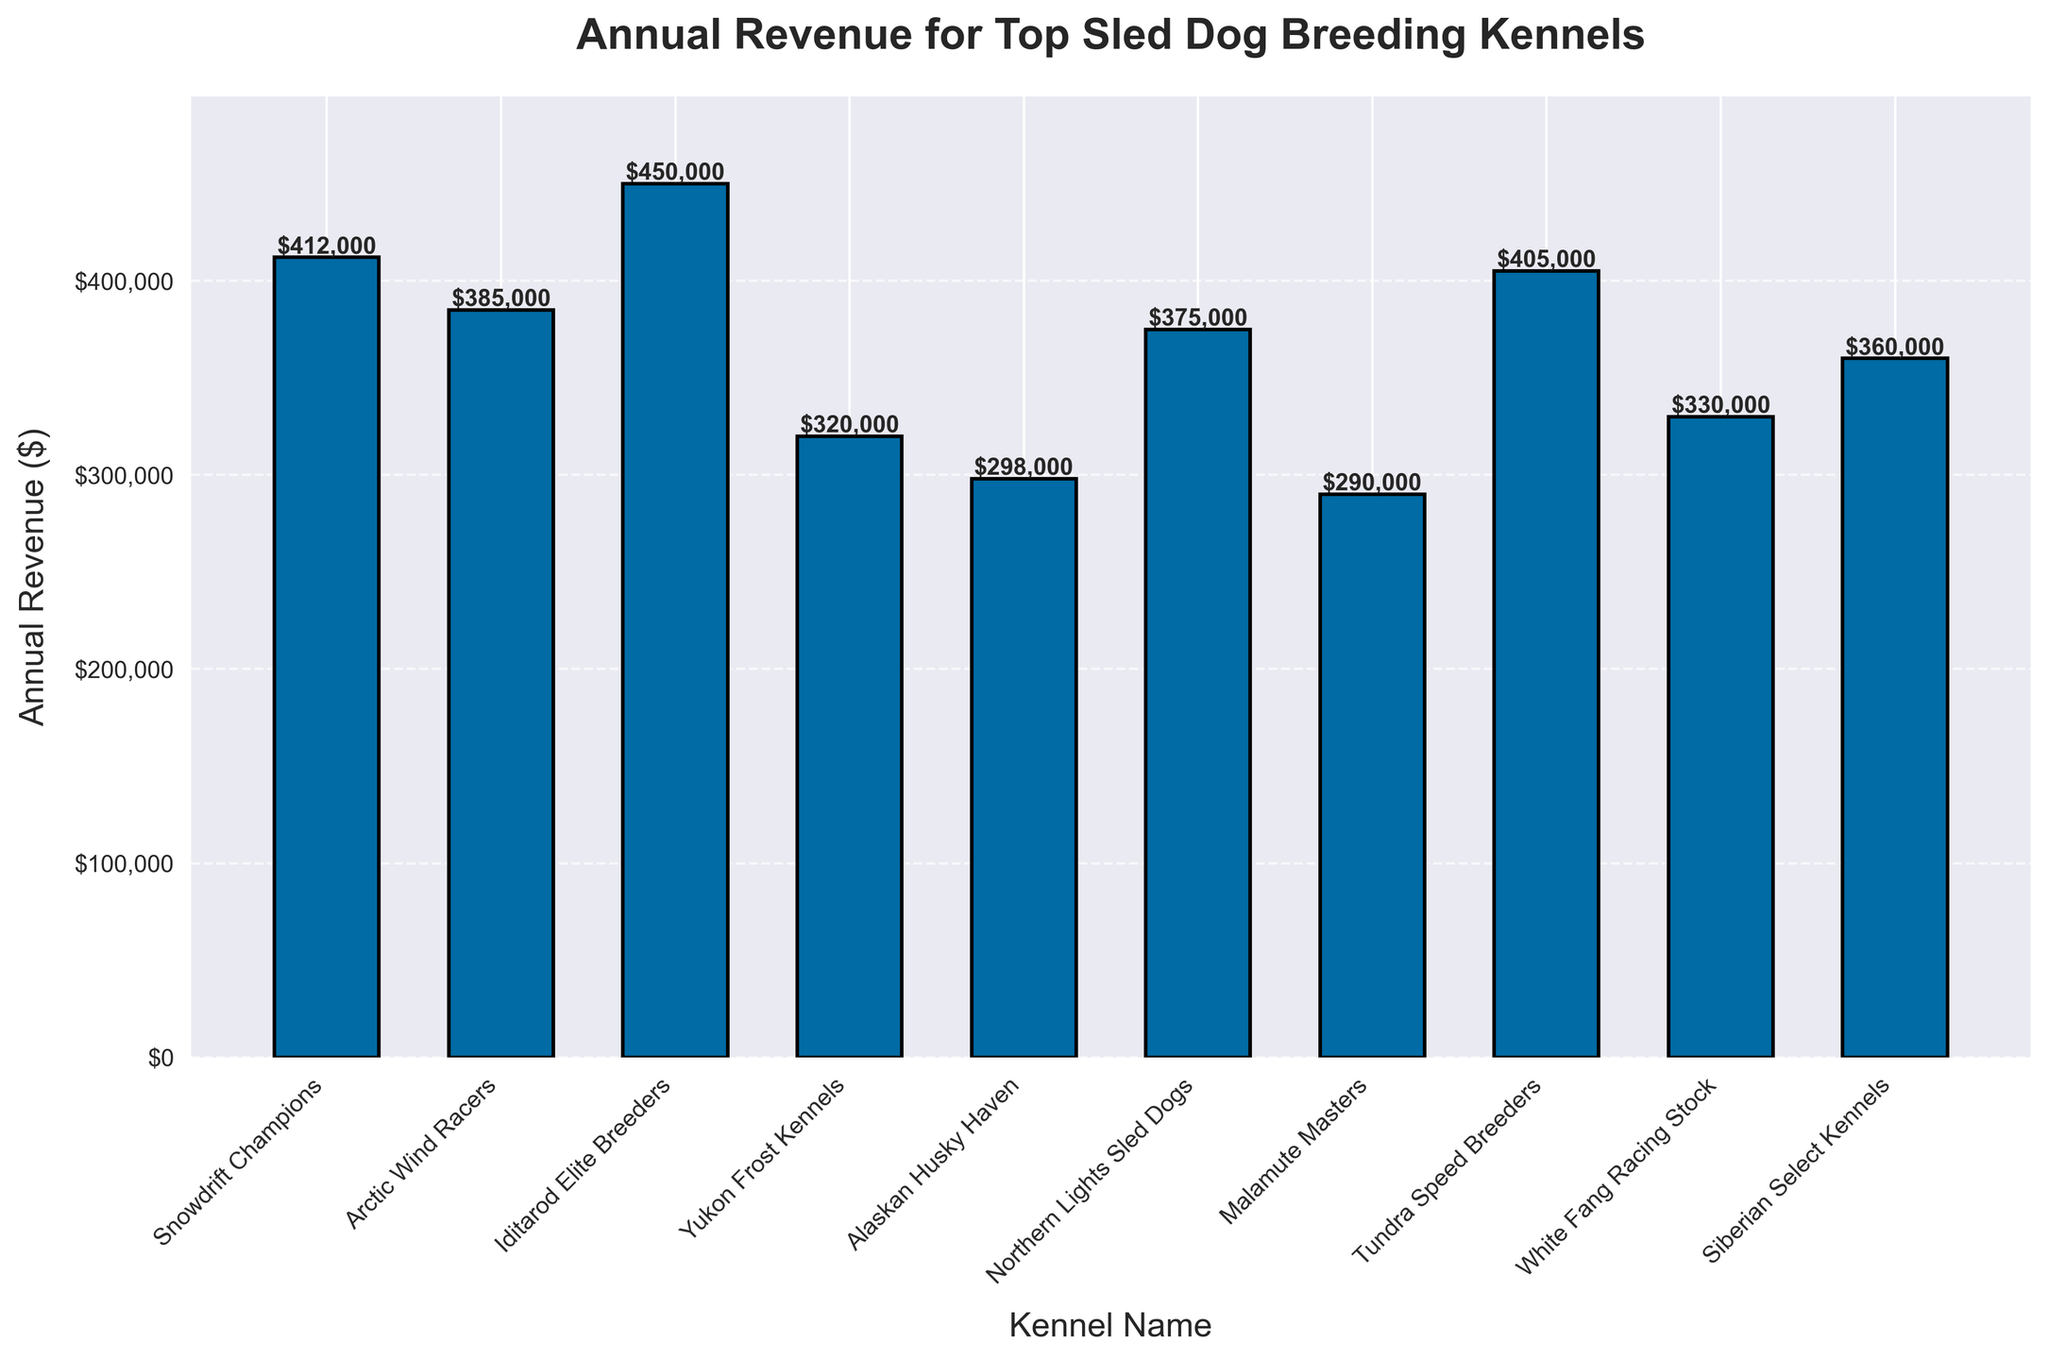Which kennel has the highest annual revenue? By examining the heights of the bars, the kennel with the highest bar represents the highest annual revenue. "Iditarod Elite Breeders" has the highest bar.
Answer: Iditarod Elite Breeders What is the total annual revenue of Artic Wind Racers and Tundra Speed Breeders? Add the annual revenue values of "Arctic Wind Racers" ($385,000) and "Tundra Speed Breeders" ($405,000). The total is $385,000 + $405,000.
Answer: $790,000 Which kennel shows the lowest annual revenue? By focusing on the shortest bar in the chart, "Alaskan Husky Haven" has the shortest bar indicating the lowest annual revenue.
Answer: Alaskan Husky Haven What is the difference in annual revenue between Northern Lights Sled Dogs and White Fang Racing Stock? Subtract the annual revenue of White Fang Racing Stock ($330,000) from Northern Lights Sled Dogs ($375,000). $375,000 - $330,000.
Answer: $45,000 How much more revenue does Snowdrift Champions generate compared to Malamute Masters? Subtract the revenue of Malamute Masters ($290,000) from Snowdrift Champions ($412,000). $412,000 - $290,000.
Answer: $122,000 What is the average annual revenue of all listed kennels? Sum all the annual revenues and divide by the number of kennels. (412,000 + 385,000 + 450,000 + 320,000 + 298,000 + 375,000 + 290,000 + 405,000 + 330,000 + 360,000) / 10.
Answer: $362,500 Which kennels have an annual revenue greater than $400,000? Identify the kennels with bars higher than the $400,000 mark: "Snowdrift Champions," "Iditarod Elite Breeders," and "Tundra Speed Breeders."
Answer: Snowdrift Champions, Iditarod Elite Breeders, Tundra Speed Breeders What is the median annual revenue of the kennels? Order the kennels' revenues and find the middle value. Ordered: 290,000, 298,000, 320,000, 330,000, 360,000, 375,000, 385,000, 405,000, 412,000, 450,000. Middle value is (360,000 + 375,000) / 2.
Answer: $367,500 Which kennel had a larger annual revenue, Siberian Select Kennels or Yukon Frost Kennels, and by how much? Subtract the lower annual revenue from the higher one. Siberian Select Kennels ($360,000) - Yukon Frost Kennels ($320,000).
Answer: $40,000 Between Northern Lights Sled Dogs and Arctic Wind Racers, which had closer annual revenue to Tundra Speed Breeders and by how much? Compare the differences: Difference with Northern Lights Sled Dogs ($405,000 - $375,000 = $30,000). Difference with Arctic Wind Racers ($405,000 - $385,000 = $20,000). Arctic Wind Racers is closer by $10,000.
Answer: Arctic Wind Racers, $10,000 